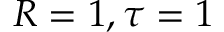Convert formula to latex. <formula><loc_0><loc_0><loc_500><loc_500>R = 1 , \tau = 1</formula> 